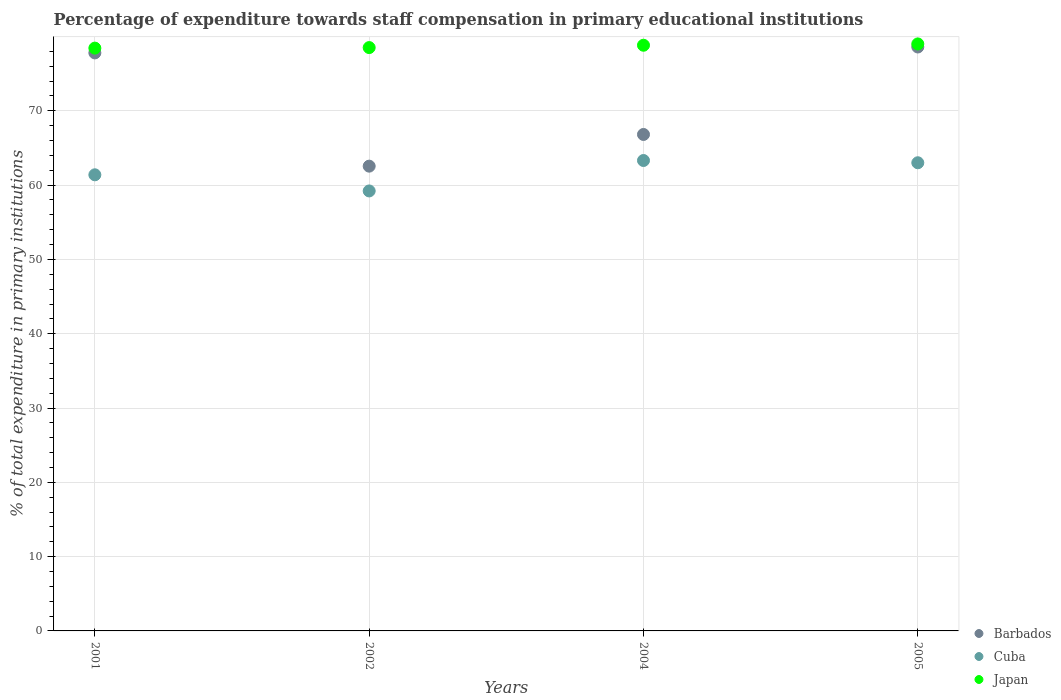How many different coloured dotlines are there?
Offer a very short reply. 3. Is the number of dotlines equal to the number of legend labels?
Your answer should be very brief. Yes. What is the percentage of expenditure towards staff compensation in Japan in 2004?
Offer a very short reply. 78.83. Across all years, what is the maximum percentage of expenditure towards staff compensation in Barbados?
Your response must be concise. 78.59. Across all years, what is the minimum percentage of expenditure towards staff compensation in Japan?
Ensure brevity in your answer.  78.44. What is the total percentage of expenditure towards staff compensation in Barbados in the graph?
Keep it short and to the point. 285.76. What is the difference between the percentage of expenditure towards staff compensation in Barbados in 2001 and that in 2004?
Give a very brief answer. 10.98. What is the difference between the percentage of expenditure towards staff compensation in Barbados in 2001 and the percentage of expenditure towards staff compensation in Cuba in 2005?
Provide a succinct answer. 14.79. What is the average percentage of expenditure towards staff compensation in Barbados per year?
Offer a very short reply. 71.44. In the year 2001, what is the difference between the percentage of expenditure towards staff compensation in Japan and percentage of expenditure towards staff compensation in Cuba?
Your answer should be compact. 17.05. In how many years, is the percentage of expenditure towards staff compensation in Cuba greater than 42 %?
Your answer should be compact. 4. What is the ratio of the percentage of expenditure towards staff compensation in Barbados in 2001 to that in 2005?
Offer a very short reply. 0.99. Is the percentage of expenditure towards staff compensation in Japan in 2001 less than that in 2002?
Ensure brevity in your answer.  Yes. Is the difference between the percentage of expenditure towards staff compensation in Japan in 2001 and 2004 greater than the difference between the percentage of expenditure towards staff compensation in Cuba in 2001 and 2004?
Give a very brief answer. Yes. What is the difference between the highest and the second highest percentage of expenditure towards staff compensation in Barbados?
Offer a very short reply. 0.8. What is the difference between the highest and the lowest percentage of expenditure towards staff compensation in Barbados?
Your answer should be very brief. 16.04. Is the percentage of expenditure towards staff compensation in Barbados strictly greater than the percentage of expenditure towards staff compensation in Cuba over the years?
Provide a succinct answer. Yes. How many dotlines are there?
Offer a terse response. 3. Does the graph contain grids?
Your answer should be very brief. Yes. Where does the legend appear in the graph?
Your answer should be compact. Bottom right. What is the title of the graph?
Make the answer very short. Percentage of expenditure towards staff compensation in primary educational institutions. Does "Cabo Verde" appear as one of the legend labels in the graph?
Give a very brief answer. No. What is the label or title of the X-axis?
Your answer should be compact. Years. What is the label or title of the Y-axis?
Ensure brevity in your answer.  % of total expenditure in primary institutions. What is the % of total expenditure in primary institutions of Barbados in 2001?
Give a very brief answer. 77.8. What is the % of total expenditure in primary institutions of Cuba in 2001?
Offer a very short reply. 61.39. What is the % of total expenditure in primary institutions of Japan in 2001?
Your answer should be compact. 78.44. What is the % of total expenditure in primary institutions in Barbados in 2002?
Your answer should be compact. 62.55. What is the % of total expenditure in primary institutions of Cuba in 2002?
Your answer should be compact. 59.22. What is the % of total expenditure in primary institutions of Japan in 2002?
Make the answer very short. 78.51. What is the % of total expenditure in primary institutions in Barbados in 2004?
Your answer should be very brief. 66.82. What is the % of total expenditure in primary institutions of Cuba in 2004?
Give a very brief answer. 63.31. What is the % of total expenditure in primary institutions in Japan in 2004?
Provide a succinct answer. 78.83. What is the % of total expenditure in primary institutions in Barbados in 2005?
Provide a short and direct response. 78.59. What is the % of total expenditure in primary institutions in Cuba in 2005?
Make the answer very short. 63.01. What is the % of total expenditure in primary institutions in Japan in 2005?
Provide a succinct answer. 79.01. Across all years, what is the maximum % of total expenditure in primary institutions of Barbados?
Provide a succinct answer. 78.59. Across all years, what is the maximum % of total expenditure in primary institutions in Cuba?
Offer a terse response. 63.31. Across all years, what is the maximum % of total expenditure in primary institutions in Japan?
Your answer should be very brief. 79.01. Across all years, what is the minimum % of total expenditure in primary institutions in Barbados?
Your response must be concise. 62.55. Across all years, what is the minimum % of total expenditure in primary institutions of Cuba?
Keep it short and to the point. 59.22. Across all years, what is the minimum % of total expenditure in primary institutions of Japan?
Give a very brief answer. 78.44. What is the total % of total expenditure in primary institutions in Barbados in the graph?
Give a very brief answer. 285.76. What is the total % of total expenditure in primary institutions of Cuba in the graph?
Keep it short and to the point. 246.93. What is the total % of total expenditure in primary institutions in Japan in the graph?
Provide a succinct answer. 314.79. What is the difference between the % of total expenditure in primary institutions in Barbados in 2001 and that in 2002?
Provide a succinct answer. 15.24. What is the difference between the % of total expenditure in primary institutions of Cuba in 2001 and that in 2002?
Offer a terse response. 2.17. What is the difference between the % of total expenditure in primary institutions of Japan in 2001 and that in 2002?
Offer a very short reply. -0.07. What is the difference between the % of total expenditure in primary institutions in Barbados in 2001 and that in 2004?
Your answer should be compact. 10.98. What is the difference between the % of total expenditure in primary institutions in Cuba in 2001 and that in 2004?
Offer a terse response. -1.92. What is the difference between the % of total expenditure in primary institutions in Japan in 2001 and that in 2004?
Make the answer very short. -0.39. What is the difference between the % of total expenditure in primary institutions in Barbados in 2001 and that in 2005?
Make the answer very short. -0.8. What is the difference between the % of total expenditure in primary institutions in Cuba in 2001 and that in 2005?
Provide a succinct answer. -1.62. What is the difference between the % of total expenditure in primary institutions in Japan in 2001 and that in 2005?
Give a very brief answer. -0.56. What is the difference between the % of total expenditure in primary institutions of Barbados in 2002 and that in 2004?
Your answer should be compact. -4.26. What is the difference between the % of total expenditure in primary institutions in Cuba in 2002 and that in 2004?
Provide a short and direct response. -4.1. What is the difference between the % of total expenditure in primary institutions in Japan in 2002 and that in 2004?
Offer a terse response. -0.32. What is the difference between the % of total expenditure in primary institutions in Barbados in 2002 and that in 2005?
Provide a short and direct response. -16.04. What is the difference between the % of total expenditure in primary institutions in Cuba in 2002 and that in 2005?
Ensure brevity in your answer.  -3.79. What is the difference between the % of total expenditure in primary institutions in Japan in 2002 and that in 2005?
Your answer should be compact. -0.49. What is the difference between the % of total expenditure in primary institutions in Barbados in 2004 and that in 2005?
Give a very brief answer. -11.77. What is the difference between the % of total expenditure in primary institutions of Cuba in 2004 and that in 2005?
Give a very brief answer. 0.3. What is the difference between the % of total expenditure in primary institutions in Japan in 2004 and that in 2005?
Give a very brief answer. -0.18. What is the difference between the % of total expenditure in primary institutions of Barbados in 2001 and the % of total expenditure in primary institutions of Cuba in 2002?
Offer a very short reply. 18.58. What is the difference between the % of total expenditure in primary institutions of Barbados in 2001 and the % of total expenditure in primary institutions of Japan in 2002?
Your answer should be very brief. -0.72. What is the difference between the % of total expenditure in primary institutions in Cuba in 2001 and the % of total expenditure in primary institutions in Japan in 2002?
Ensure brevity in your answer.  -17.12. What is the difference between the % of total expenditure in primary institutions in Barbados in 2001 and the % of total expenditure in primary institutions in Cuba in 2004?
Provide a succinct answer. 14.48. What is the difference between the % of total expenditure in primary institutions in Barbados in 2001 and the % of total expenditure in primary institutions in Japan in 2004?
Provide a succinct answer. -1.03. What is the difference between the % of total expenditure in primary institutions of Cuba in 2001 and the % of total expenditure in primary institutions of Japan in 2004?
Ensure brevity in your answer.  -17.44. What is the difference between the % of total expenditure in primary institutions of Barbados in 2001 and the % of total expenditure in primary institutions of Cuba in 2005?
Your answer should be very brief. 14.79. What is the difference between the % of total expenditure in primary institutions in Barbados in 2001 and the % of total expenditure in primary institutions in Japan in 2005?
Offer a very short reply. -1.21. What is the difference between the % of total expenditure in primary institutions in Cuba in 2001 and the % of total expenditure in primary institutions in Japan in 2005?
Give a very brief answer. -17.62. What is the difference between the % of total expenditure in primary institutions of Barbados in 2002 and the % of total expenditure in primary institutions of Cuba in 2004?
Keep it short and to the point. -0.76. What is the difference between the % of total expenditure in primary institutions of Barbados in 2002 and the % of total expenditure in primary institutions of Japan in 2004?
Make the answer very short. -16.27. What is the difference between the % of total expenditure in primary institutions of Cuba in 2002 and the % of total expenditure in primary institutions of Japan in 2004?
Your response must be concise. -19.61. What is the difference between the % of total expenditure in primary institutions in Barbados in 2002 and the % of total expenditure in primary institutions in Cuba in 2005?
Ensure brevity in your answer.  -0.46. What is the difference between the % of total expenditure in primary institutions in Barbados in 2002 and the % of total expenditure in primary institutions in Japan in 2005?
Your response must be concise. -16.45. What is the difference between the % of total expenditure in primary institutions of Cuba in 2002 and the % of total expenditure in primary institutions of Japan in 2005?
Ensure brevity in your answer.  -19.79. What is the difference between the % of total expenditure in primary institutions in Barbados in 2004 and the % of total expenditure in primary institutions in Cuba in 2005?
Keep it short and to the point. 3.81. What is the difference between the % of total expenditure in primary institutions in Barbados in 2004 and the % of total expenditure in primary institutions in Japan in 2005?
Offer a terse response. -12.19. What is the difference between the % of total expenditure in primary institutions in Cuba in 2004 and the % of total expenditure in primary institutions in Japan in 2005?
Ensure brevity in your answer.  -15.69. What is the average % of total expenditure in primary institutions of Barbados per year?
Offer a very short reply. 71.44. What is the average % of total expenditure in primary institutions of Cuba per year?
Keep it short and to the point. 61.73. What is the average % of total expenditure in primary institutions of Japan per year?
Provide a short and direct response. 78.7. In the year 2001, what is the difference between the % of total expenditure in primary institutions in Barbados and % of total expenditure in primary institutions in Cuba?
Your answer should be compact. 16.41. In the year 2001, what is the difference between the % of total expenditure in primary institutions in Barbados and % of total expenditure in primary institutions in Japan?
Keep it short and to the point. -0.64. In the year 2001, what is the difference between the % of total expenditure in primary institutions in Cuba and % of total expenditure in primary institutions in Japan?
Your answer should be compact. -17.05. In the year 2002, what is the difference between the % of total expenditure in primary institutions in Barbados and % of total expenditure in primary institutions in Cuba?
Your answer should be compact. 3.34. In the year 2002, what is the difference between the % of total expenditure in primary institutions in Barbados and % of total expenditure in primary institutions in Japan?
Offer a terse response. -15.96. In the year 2002, what is the difference between the % of total expenditure in primary institutions of Cuba and % of total expenditure in primary institutions of Japan?
Provide a succinct answer. -19.3. In the year 2004, what is the difference between the % of total expenditure in primary institutions of Barbados and % of total expenditure in primary institutions of Cuba?
Offer a very short reply. 3.51. In the year 2004, what is the difference between the % of total expenditure in primary institutions in Barbados and % of total expenditure in primary institutions in Japan?
Provide a short and direct response. -12.01. In the year 2004, what is the difference between the % of total expenditure in primary institutions in Cuba and % of total expenditure in primary institutions in Japan?
Your answer should be very brief. -15.51. In the year 2005, what is the difference between the % of total expenditure in primary institutions of Barbados and % of total expenditure in primary institutions of Cuba?
Your response must be concise. 15.58. In the year 2005, what is the difference between the % of total expenditure in primary institutions in Barbados and % of total expenditure in primary institutions in Japan?
Keep it short and to the point. -0.41. In the year 2005, what is the difference between the % of total expenditure in primary institutions of Cuba and % of total expenditure in primary institutions of Japan?
Provide a short and direct response. -15.99. What is the ratio of the % of total expenditure in primary institutions in Barbados in 2001 to that in 2002?
Keep it short and to the point. 1.24. What is the ratio of the % of total expenditure in primary institutions of Cuba in 2001 to that in 2002?
Provide a short and direct response. 1.04. What is the ratio of the % of total expenditure in primary institutions of Japan in 2001 to that in 2002?
Your response must be concise. 1. What is the ratio of the % of total expenditure in primary institutions in Barbados in 2001 to that in 2004?
Give a very brief answer. 1.16. What is the ratio of the % of total expenditure in primary institutions in Cuba in 2001 to that in 2004?
Offer a very short reply. 0.97. What is the ratio of the % of total expenditure in primary institutions of Barbados in 2001 to that in 2005?
Offer a terse response. 0.99. What is the ratio of the % of total expenditure in primary institutions of Cuba in 2001 to that in 2005?
Give a very brief answer. 0.97. What is the ratio of the % of total expenditure in primary institutions in Barbados in 2002 to that in 2004?
Offer a very short reply. 0.94. What is the ratio of the % of total expenditure in primary institutions of Cuba in 2002 to that in 2004?
Make the answer very short. 0.94. What is the ratio of the % of total expenditure in primary institutions of Japan in 2002 to that in 2004?
Ensure brevity in your answer.  1. What is the ratio of the % of total expenditure in primary institutions of Barbados in 2002 to that in 2005?
Provide a short and direct response. 0.8. What is the ratio of the % of total expenditure in primary institutions in Cuba in 2002 to that in 2005?
Offer a very short reply. 0.94. What is the ratio of the % of total expenditure in primary institutions in Japan in 2002 to that in 2005?
Your response must be concise. 0.99. What is the ratio of the % of total expenditure in primary institutions in Barbados in 2004 to that in 2005?
Give a very brief answer. 0.85. What is the ratio of the % of total expenditure in primary institutions of Cuba in 2004 to that in 2005?
Your answer should be very brief. 1. What is the difference between the highest and the second highest % of total expenditure in primary institutions in Barbados?
Provide a short and direct response. 0.8. What is the difference between the highest and the second highest % of total expenditure in primary institutions of Cuba?
Keep it short and to the point. 0.3. What is the difference between the highest and the second highest % of total expenditure in primary institutions in Japan?
Give a very brief answer. 0.18. What is the difference between the highest and the lowest % of total expenditure in primary institutions of Barbados?
Your response must be concise. 16.04. What is the difference between the highest and the lowest % of total expenditure in primary institutions in Cuba?
Provide a succinct answer. 4.1. What is the difference between the highest and the lowest % of total expenditure in primary institutions of Japan?
Keep it short and to the point. 0.56. 